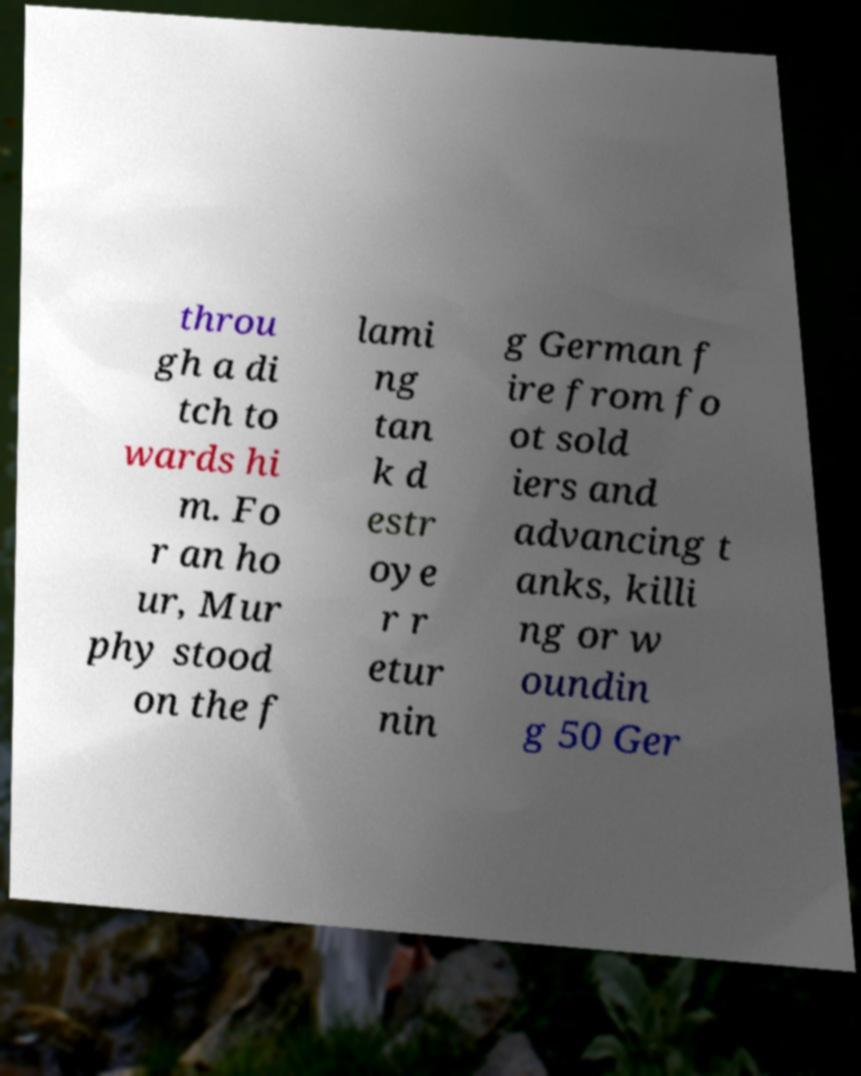Please read and relay the text visible in this image. What does it say? throu gh a di tch to wards hi m. Fo r an ho ur, Mur phy stood on the f lami ng tan k d estr oye r r etur nin g German f ire from fo ot sold iers and advancing t anks, killi ng or w oundin g 50 Ger 